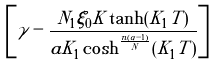<formula> <loc_0><loc_0><loc_500><loc_500>\left [ \gamma - \frac { N _ { 1 } \xi _ { 0 } K \tanh ( K _ { 1 } T ) } { a K _ { 1 } \cosh ^ { \frac { n ( \alpha - 1 ) } { N } } ( K _ { 1 } T ) } \right ]</formula> 